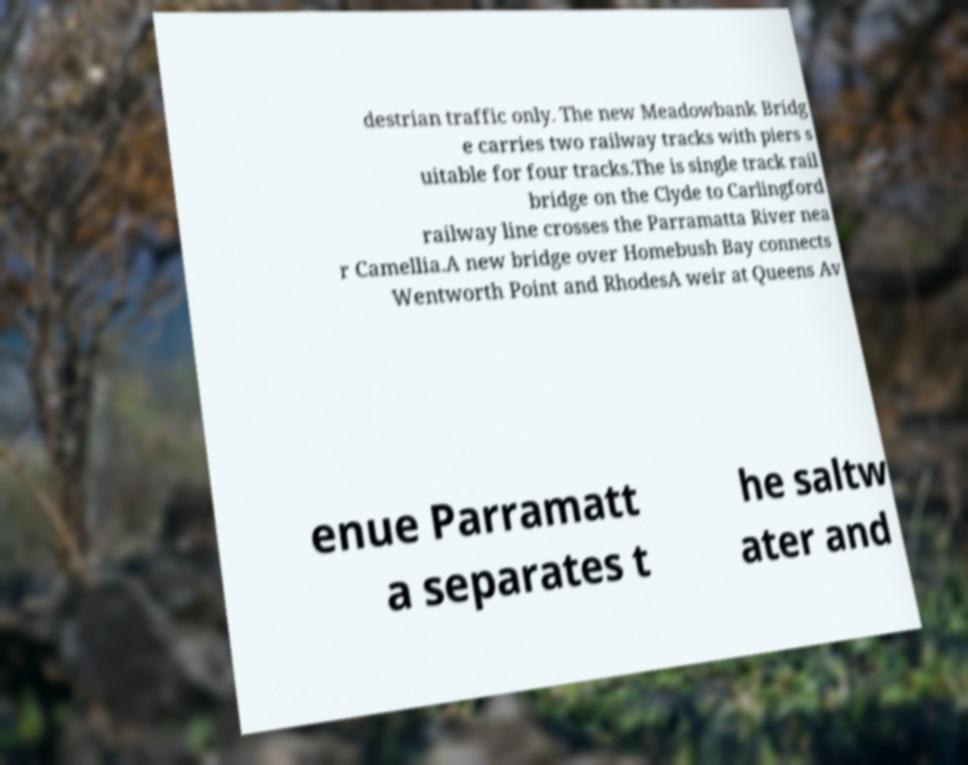Please read and relay the text visible in this image. What does it say? destrian traffic only. The new Meadowbank Bridg e carries two railway tracks with piers s uitable for four tracks.The is single track rail bridge on the Clyde to Carlingford railway line crosses the Parramatta River nea r Camellia.A new bridge over Homebush Bay connects Wentworth Point and RhodesA weir at Queens Av enue Parramatt a separates t he saltw ater and 